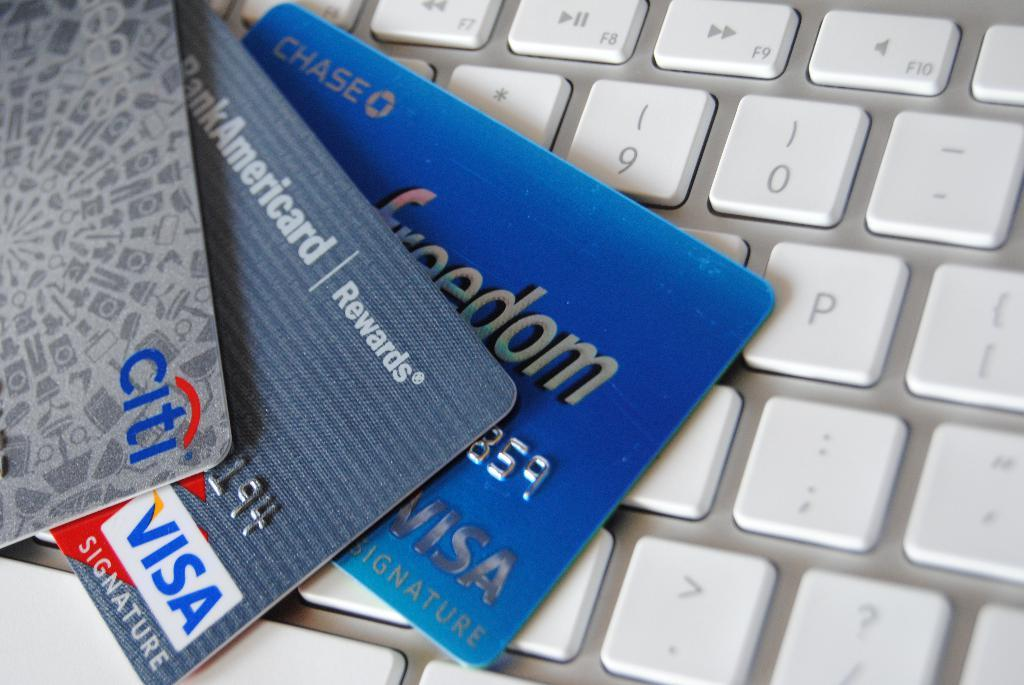<image>
Share a concise interpretation of the image provided. A citi bank and two visa cards are fanned out on a section of a keyboard. 